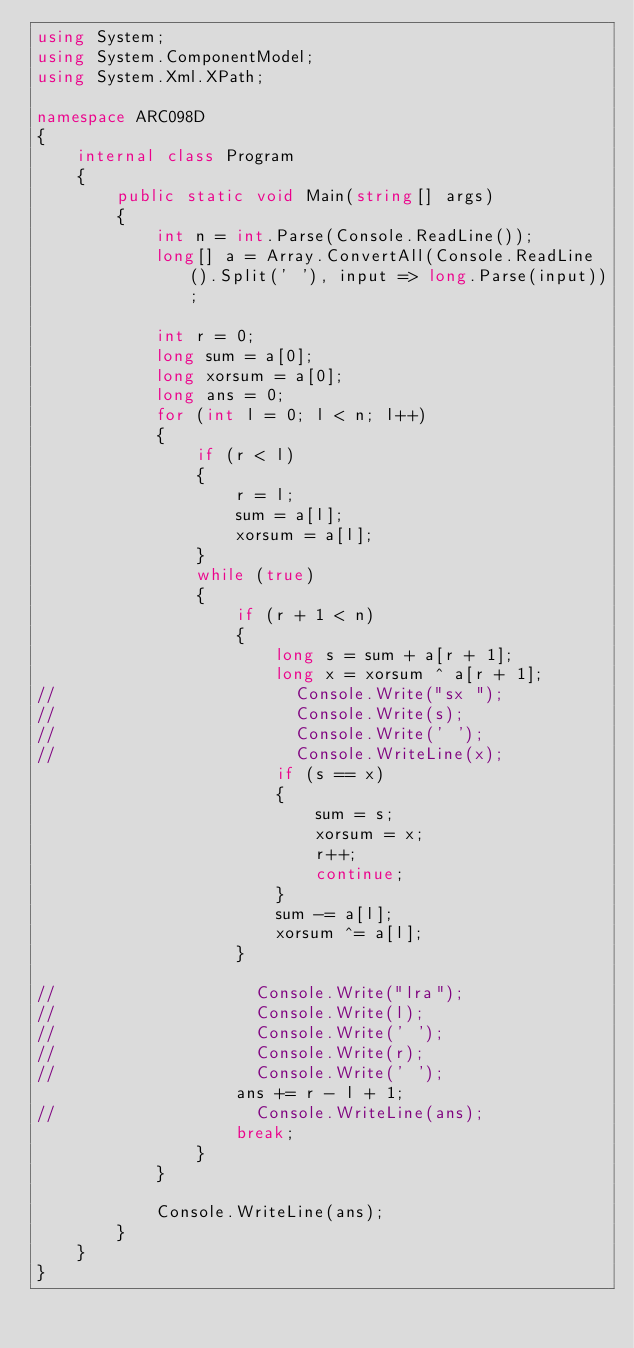Convert code to text. <code><loc_0><loc_0><loc_500><loc_500><_C#_>using System;
using System.ComponentModel;
using System.Xml.XPath;

namespace ARC098D
{
    internal class Program
    {
        public static void Main(string[] args)
        {
            int n = int.Parse(Console.ReadLine());
            long[] a = Array.ConvertAll(Console.ReadLine().Split(' '), input => long.Parse(input));

            int r = 0;
            long sum = a[0];
            long xorsum = a[0];
            long ans = 0;
            for (int l = 0; l < n; l++)
            {
                if (r < l)
                {
                    r = l;
                    sum = a[l];
                    xorsum = a[l];
                }
                while (true)
                {
                    if (r + 1 < n)
                    {
                        long s = sum + a[r + 1];
                        long x = xorsum ^ a[r + 1];
//                        Console.Write("sx ");
//                        Console.Write(s);
//                        Console.Write(' ');
//                        Console.WriteLine(x);
                        if (s == x)
                        {
                            sum = s;
                            xorsum = x;
                            r++;
                            continue;
                        }
                        sum -= a[l];
                        xorsum ^= a[l];
                    }

//                    Console.Write("lra");
//                    Console.Write(l);
//                    Console.Write(' ');
//                    Console.Write(r);
//                    Console.Write(' ');
                    ans += r - l + 1;
//                    Console.WriteLine(ans);
                    break;
                }
            }

            Console.WriteLine(ans);
        }
    }
}</code> 